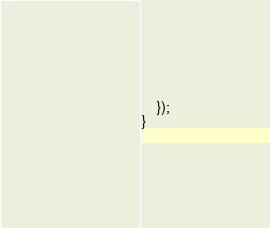<code> <loc_0><loc_0><loc_500><loc_500><_JavaScript_>    });
}
</code> 